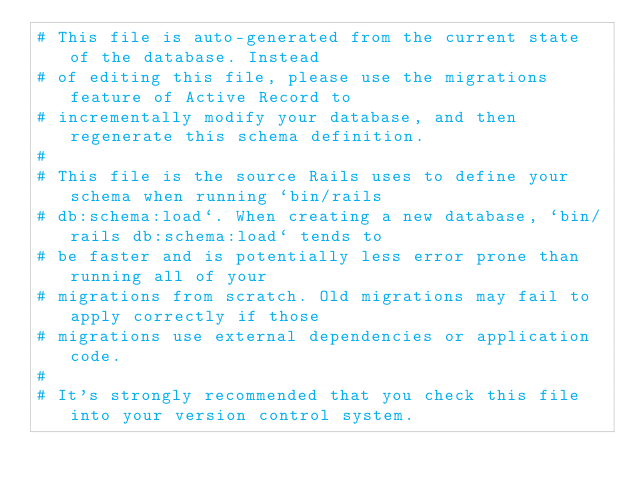<code> <loc_0><loc_0><loc_500><loc_500><_Ruby_># This file is auto-generated from the current state of the database. Instead
# of editing this file, please use the migrations feature of Active Record to
# incrementally modify your database, and then regenerate this schema definition.
#
# This file is the source Rails uses to define your schema when running `bin/rails
# db:schema:load`. When creating a new database, `bin/rails db:schema:load` tends to
# be faster and is potentially less error prone than running all of your
# migrations from scratch. Old migrations may fail to apply correctly if those
# migrations use external dependencies or application code.
#
# It's strongly recommended that you check this file into your version control system.
</code> 